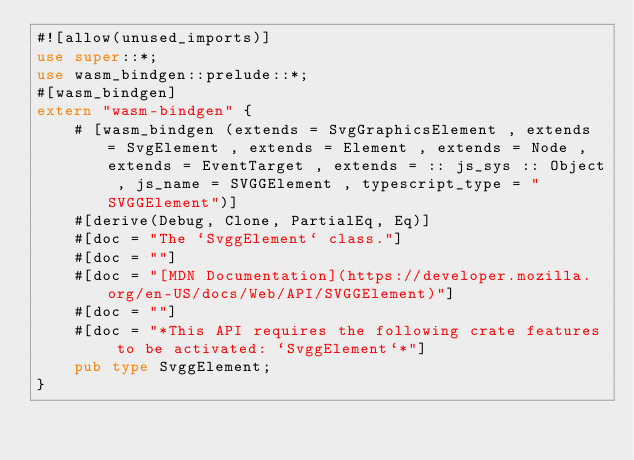Convert code to text. <code><loc_0><loc_0><loc_500><loc_500><_Rust_>#![allow(unused_imports)]
use super::*;
use wasm_bindgen::prelude::*;
#[wasm_bindgen]
extern "wasm-bindgen" {
    # [wasm_bindgen (extends = SvgGraphicsElement , extends = SvgElement , extends = Element , extends = Node , extends = EventTarget , extends = :: js_sys :: Object , js_name = SVGGElement , typescript_type = "SVGGElement")]
    #[derive(Debug, Clone, PartialEq, Eq)]
    #[doc = "The `SvggElement` class."]
    #[doc = ""]
    #[doc = "[MDN Documentation](https://developer.mozilla.org/en-US/docs/Web/API/SVGGElement)"]
    #[doc = ""]
    #[doc = "*This API requires the following crate features to be activated: `SvggElement`*"]
    pub type SvggElement;
}
</code> 